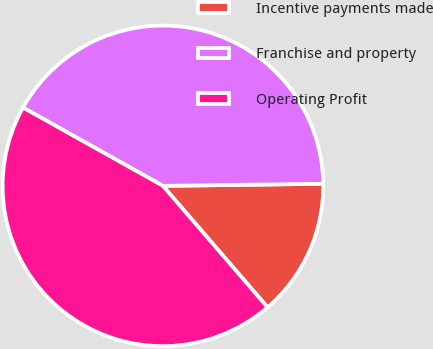Convert chart. <chart><loc_0><loc_0><loc_500><loc_500><pie_chart><fcel>Incentive payments made<fcel>Franchise and property<fcel>Operating Profit<nl><fcel>13.89%<fcel>41.67%<fcel>44.44%<nl></chart> 